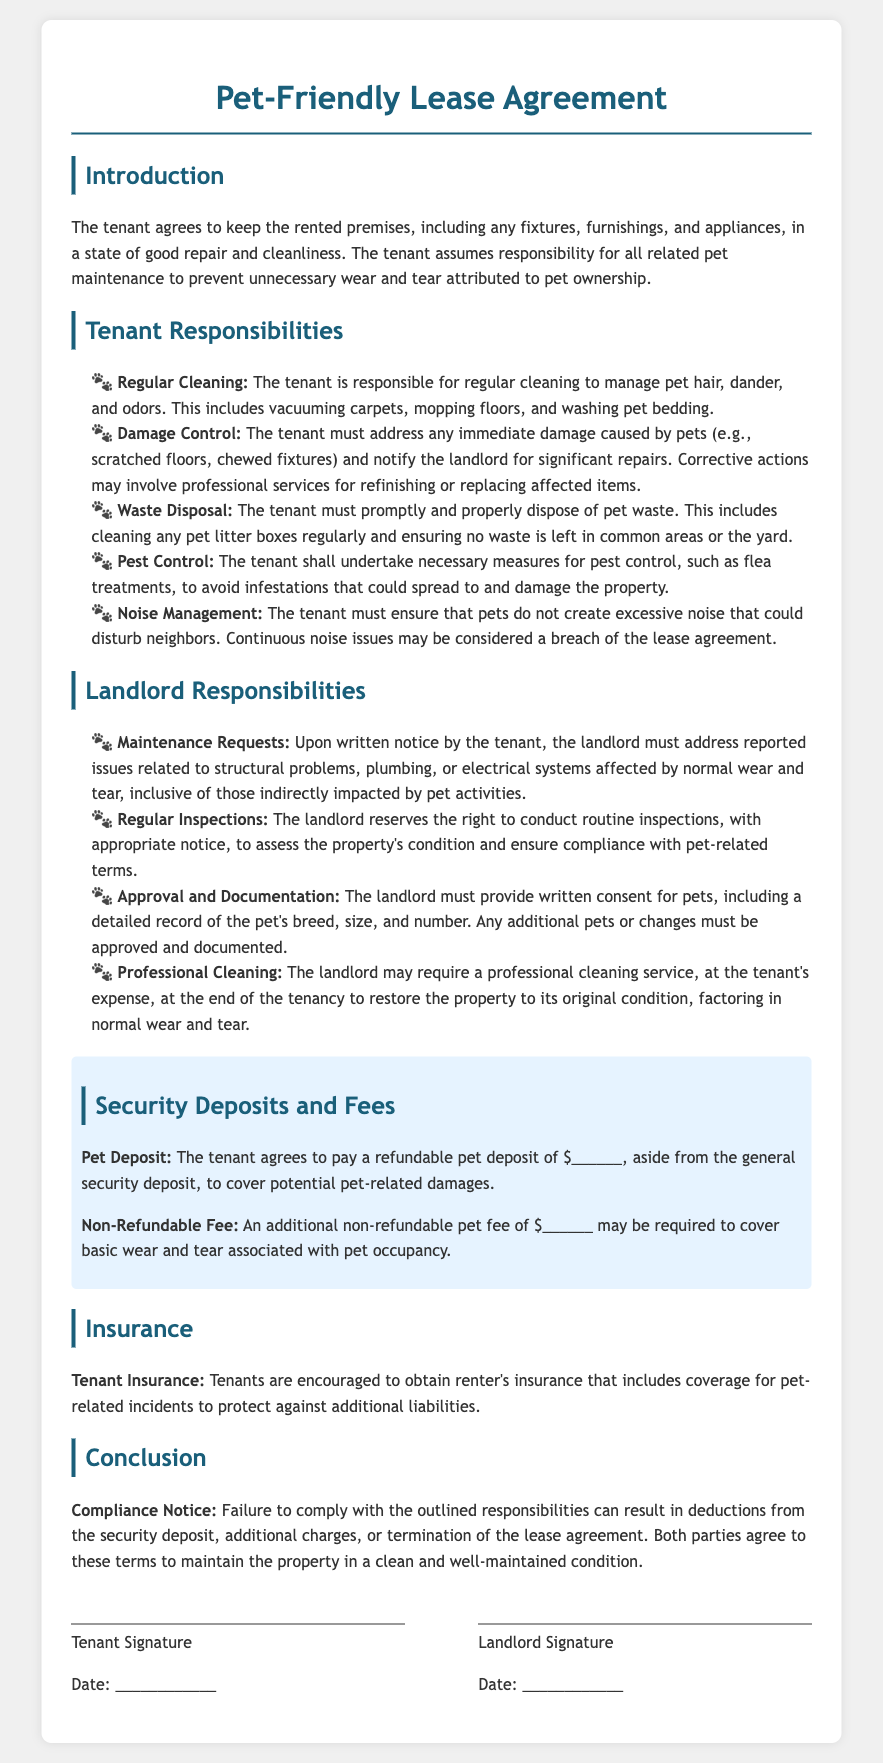What is the tenant responsible for regarding cleaning? The tenant is responsible for regular cleaning to manage pet hair, dander, and odors.
Answer: Regular cleaning What type of cleaning may the landlord require at the end of the tenancy? The landlord may require a professional cleaning service, at the tenant's expense, at the end of the tenancy.
Answer: Professional cleaning service What is the refundable pet deposit amount needed? The document specifies a refundable pet deposit amount, but it leaves a blank for the tenant to fill in.
Answer: $______ What action must the tenant take for pest control? The tenant shall undertake necessary measures for pest control, such as flea treatments.
Answer: Pest control What must the landlord provide for pet approval? The landlord must provide written consent for pets, including a detailed record of the pet's breed, size, and number.
Answer: Written consent What could be a consequence of failing to follow the outlined responsibilities? Failure to comply with the outlined responsibilities can result in deductions from the security deposit.
Answer: Deductions from the security deposit What must the tenant ensure regarding noise? The tenant must ensure that pets do not create excessive noise that could disturb neighbors.
Answer: Excessive noise What may the landlord require apart from the general security deposit? The tenant agrees to pay a refundable pet deposit apart from the general security deposit.
Answer: Refundable pet deposit What is the purpose of obtaining tenant insurance? Tenants are encouraged to obtain renter's insurance that includes coverage for pet-related incidents.
Answer: Coverage for pet-related incidents 